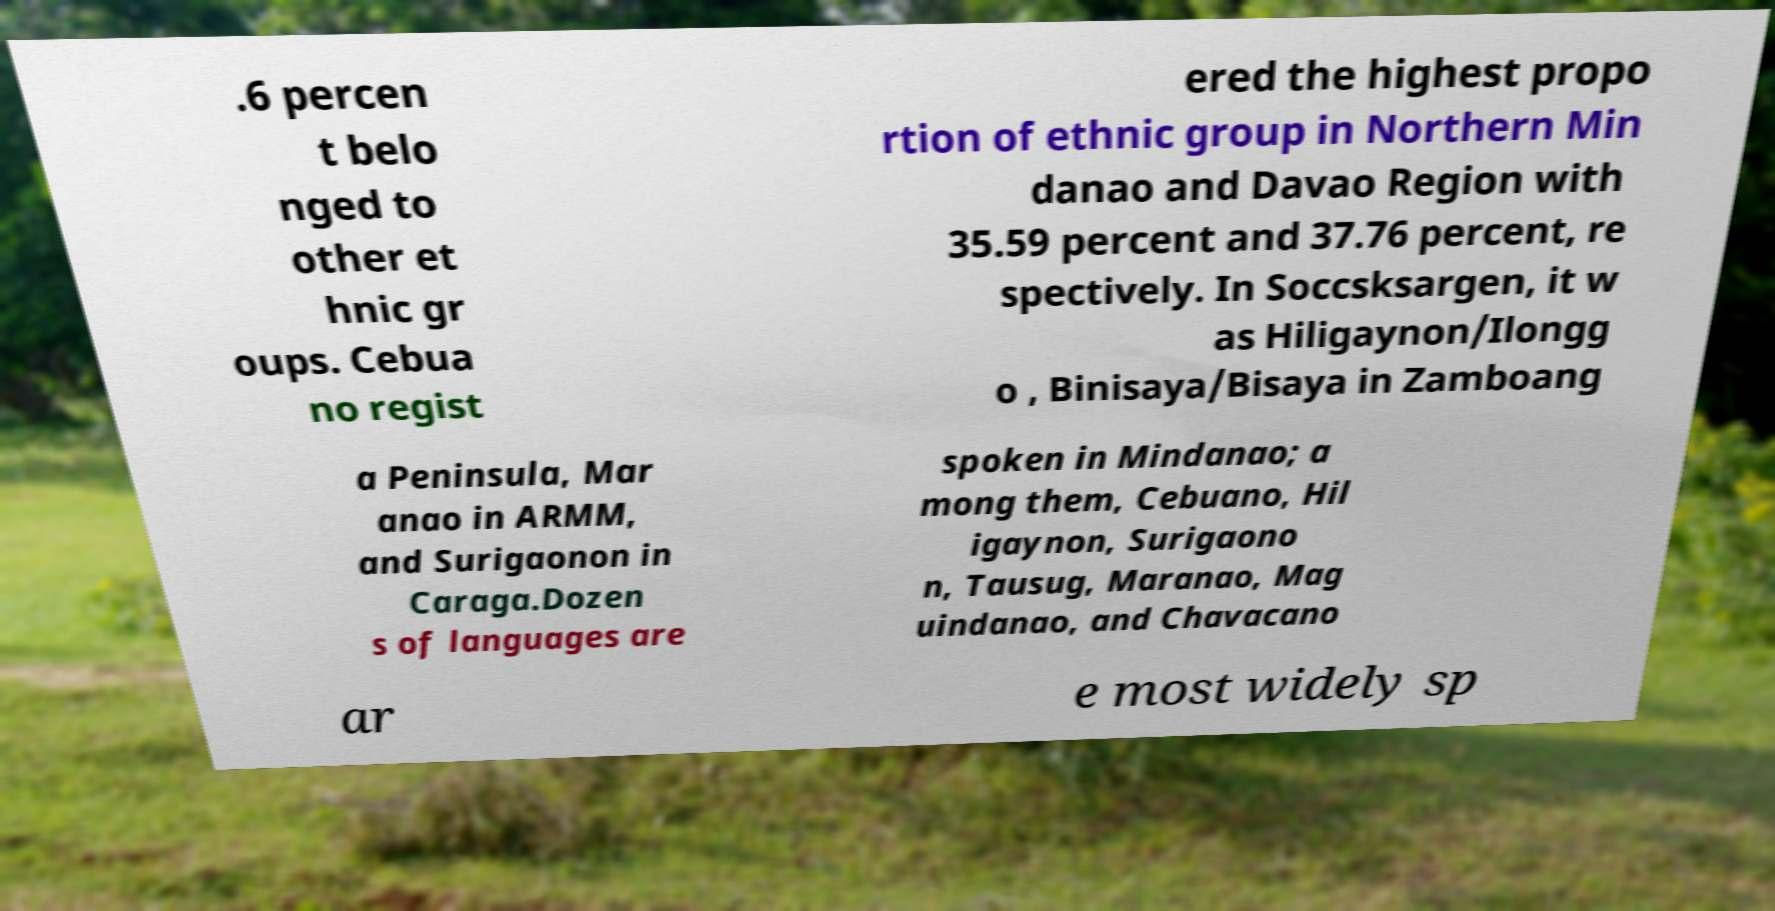Can you read and provide the text displayed in the image?This photo seems to have some interesting text. Can you extract and type it out for me? .6 percen t belo nged to other et hnic gr oups. Cebua no regist ered the highest propo rtion of ethnic group in Northern Min danao and Davao Region with 35.59 percent and 37.76 percent, re spectively. In Soccsksargen, it w as Hiligaynon/Ilongg o , Binisaya/Bisaya in Zamboang a Peninsula, Mar anao in ARMM, and Surigaonon in Caraga.Dozen s of languages are spoken in Mindanao; a mong them, Cebuano, Hil igaynon, Surigaono n, Tausug, Maranao, Mag uindanao, and Chavacano ar e most widely sp 